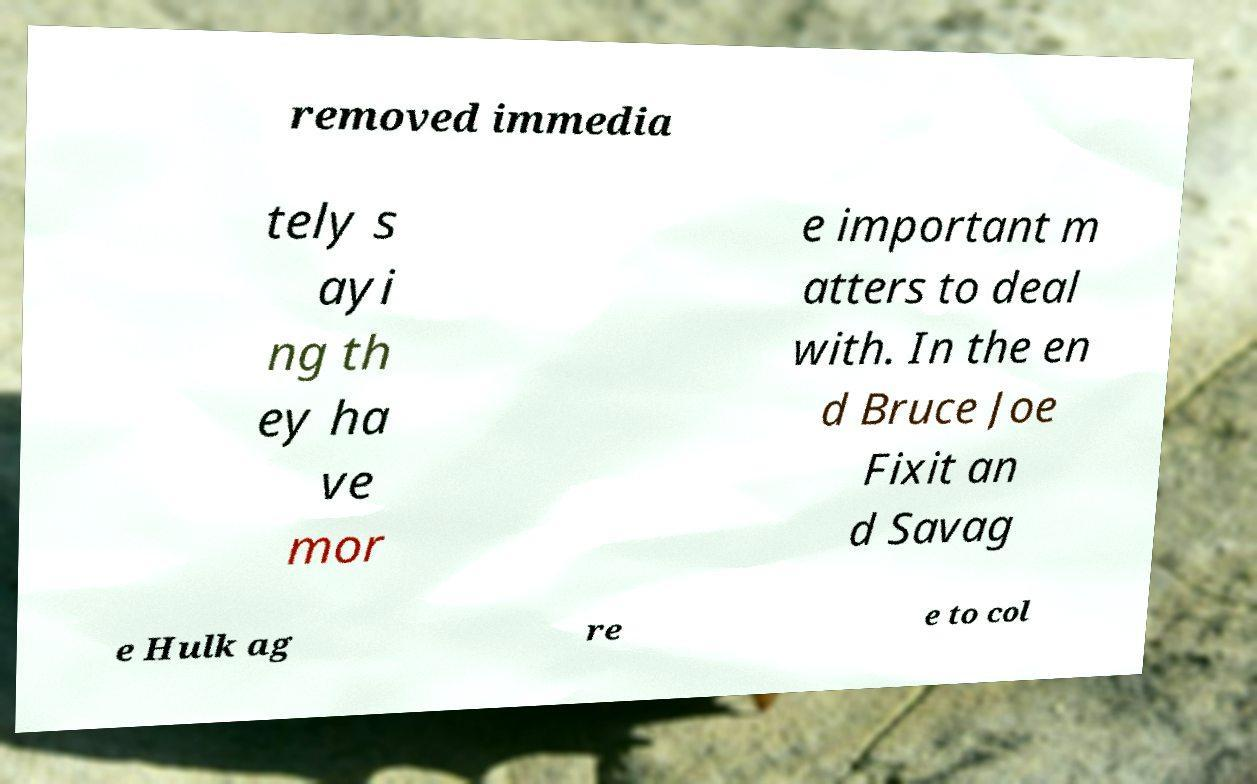There's text embedded in this image that I need extracted. Can you transcribe it verbatim? removed immedia tely s ayi ng th ey ha ve mor e important m atters to deal with. In the en d Bruce Joe Fixit an d Savag e Hulk ag re e to col 